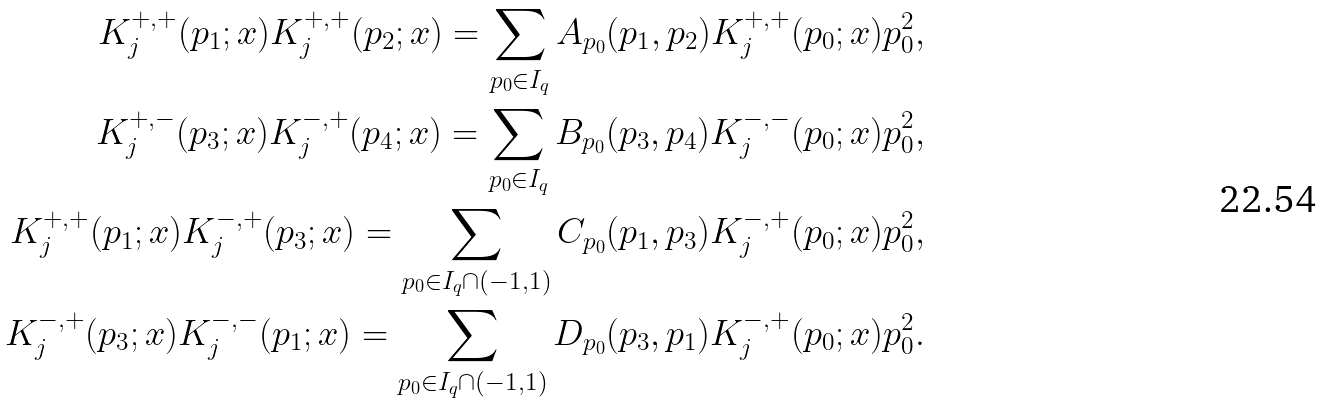Convert formula to latex. <formula><loc_0><loc_0><loc_500><loc_500>K _ { j } ^ { + , + } ( p _ { 1 } ; x ) K _ { j } ^ { + , + } ( p _ { 2 } ; x ) = \sum _ { p _ { 0 } \in I _ { q } } A _ { p _ { 0 } } ( p _ { 1 } , p _ { 2 } ) K _ { j } ^ { + , + } ( p _ { 0 } ; x ) p _ { 0 } ^ { 2 } , \\ K _ { j } ^ { + , - } ( p _ { 3 } ; x ) K _ { j } ^ { - , + } ( p _ { 4 } ; x ) = \sum _ { p _ { 0 } \in I _ { q } } B _ { p _ { 0 } } ( p _ { 3 } , p _ { 4 } ) K _ { j } ^ { - , - } ( p _ { 0 } ; x ) p _ { 0 } ^ { 2 } , \\ K _ { j } ^ { + , + } ( p _ { 1 } ; x ) K _ { j } ^ { - , + } ( p _ { 3 } ; x ) = \sum _ { p _ { 0 } \in I _ { q } \cap ( - 1 , 1 ) } C _ { p _ { 0 } } ( p _ { 1 } , p _ { 3 } ) K ^ { - , + } _ { j } ( p _ { 0 } ; x ) p _ { 0 } ^ { 2 } , \\ K _ { j } ^ { - , + } ( p _ { 3 } ; x ) K _ { j } ^ { - , - } ( p _ { 1 } ; x ) = \sum _ { p _ { 0 } \in I _ { q } \cap ( - 1 , 1 ) } D _ { p _ { 0 } } ( p _ { 3 } , p _ { 1 } ) K _ { j } ^ { - , + } ( p _ { 0 } ; x ) p _ { 0 } ^ { 2 } .</formula> 